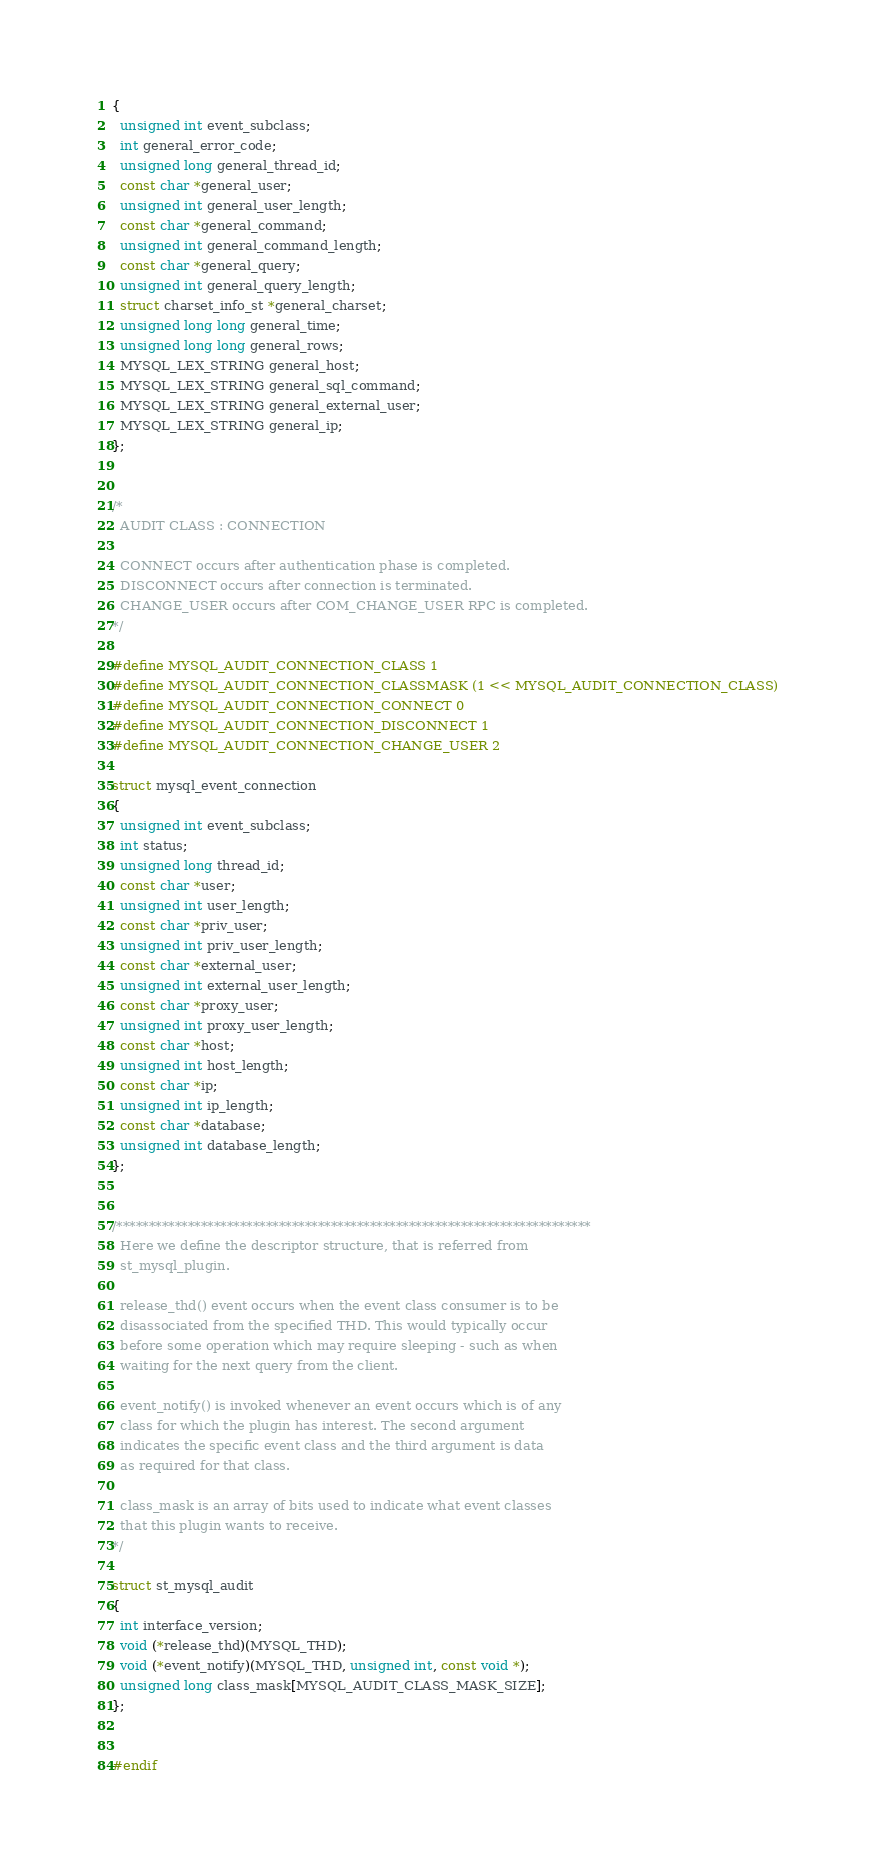Convert code to text. <code><loc_0><loc_0><loc_500><loc_500><_C_>{
  unsigned int event_subclass;
  int general_error_code;
  unsigned long general_thread_id;
  const char *general_user;
  unsigned int general_user_length;
  const char *general_command;
  unsigned int general_command_length;
  const char *general_query;
  unsigned int general_query_length;
  struct charset_info_st *general_charset;
  unsigned long long general_time;
  unsigned long long general_rows;
  MYSQL_LEX_STRING general_host;
  MYSQL_LEX_STRING general_sql_command;
  MYSQL_LEX_STRING general_external_user;
  MYSQL_LEX_STRING general_ip;
};


/*
  AUDIT CLASS : CONNECTION
  
  CONNECT occurs after authentication phase is completed.
  DISCONNECT occurs after connection is terminated.
  CHANGE_USER occurs after COM_CHANGE_USER RPC is completed.
*/

#define MYSQL_AUDIT_CONNECTION_CLASS 1
#define MYSQL_AUDIT_CONNECTION_CLASSMASK (1 << MYSQL_AUDIT_CONNECTION_CLASS)
#define MYSQL_AUDIT_CONNECTION_CONNECT 0
#define MYSQL_AUDIT_CONNECTION_DISCONNECT 1
#define MYSQL_AUDIT_CONNECTION_CHANGE_USER 2

struct mysql_event_connection
{
  unsigned int event_subclass;
  int status;
  unsigned long thread_id;
  const char *user;
  unsigned int user_length;
  const char *priv_user;
  unsigned int priv_user_length;
  const char *external_user;
  unsigned int external_user_length;
  const char *proxy_user;
  unsigned int proxy_user_length;
  const char *host;
  unsigned int host_length;
  const char *ip;
  unsigned int ip_length;
  const char *database;
  unsigned int database_length;
};


/*************************************************************************
  Here we define the descriptor structure, that is referred from
  st_mysql_plugin.

  release_thd() event occurs when the event class consumer is to be
  disassociated from the specified THD. This would typically occur
  before some operation which may require sleeping - such as when
  waiting for the next query from the client.
  
  event_notify() is invoked whenever an event occurs which is of any
  class for which the plugin has interest. The second argument
  indicates the specific event class and the third argument is data
  as required for that class.
  
  class_mask is an array of bits used to indicate what event classes
  that this plugin wants to receive.
*/

struct st_mysql_audit
{
  int interface_version;
  void (*release_thd)(MYSQL_THD);
  void (*event_notify)(MYSQL_THD, unsigned int, const void *);
  unsigned long class_mask[MYSQL_AUDIT_CLASS_MASK_SIZE];
};


#endif
</code> 